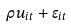<formula> <loc_0><loc_0><loc_500><loc_500>\rho u _ { i t } + \epsilon _ { i t }</formula> 